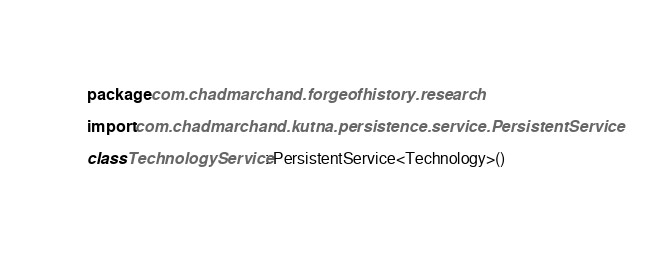Convert code to text. <code><loc_0><loc_0><loc_500><loc_500><_Kotlin_>package com.chadmarchand.forgeofhistory.research

import com.chadmarchand.kutna.persistence.service.PersistentService

class TechnologyService : PersistentService<Technology>()
</code> 